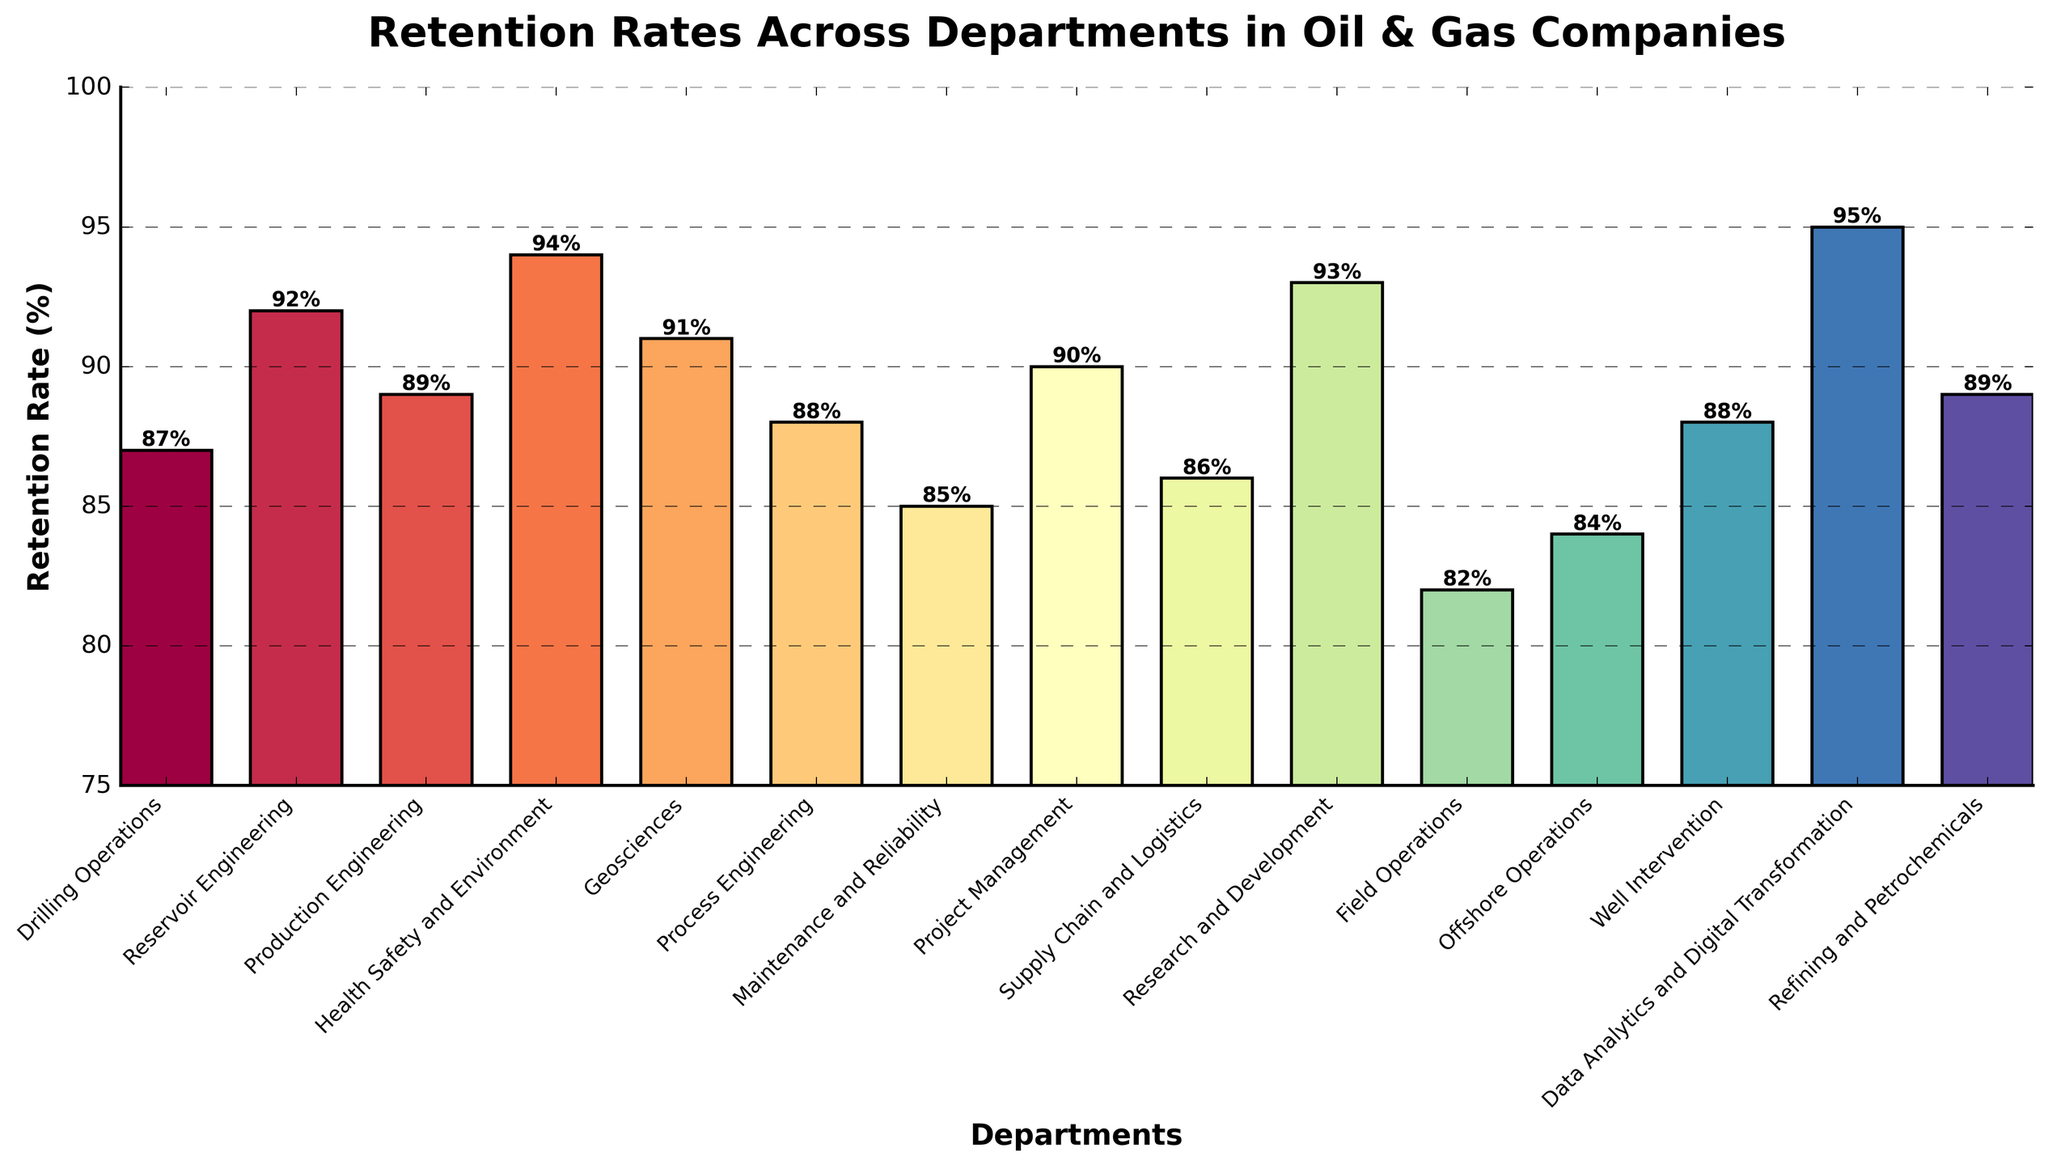What's the retention rate of the Health Safety and Environment department? Locate the bar labeled 'Health Safety and Environment' and observe its height on the y-axis, which shows retention rate. The value is also labeled above the bar.
Answer: 94% Which department has the highest retention rate? Identify the tallest bar in the chart and read the department name labeled below it. The tallest bar corresponds to 'Data Analytics and Digital Transformation' at 95%.
Answer: Data Analytics and Digital Transformation What's the average retention rate across all departments? Add up all the retention rates and then divide by the number of departments. The departments and their retention rates are: (87 + 92 + 89 + 94 + 91 + 88 + 85 + 90 + 86 + 93 + 82 + 84 + 88 + 95 + 89). The total is 1233. There are 15 departments, so the average retention rate is 1233 / 15.
Answer: 82.2% Which department has the lowest retention rate, and what is it? Identify the shortest bar in the chart and read the department name labeled below it. The shortest bar corresponds to 'Field Operations' at 82%.
Answer: Field Operations, 82% How many departments have a retention rate greater than 90%? Count the bars in the chart that extend above the 90% mark on the y-axis. The departments with retention rates above 90% are Reservoir Engineering (92%), Health Safety and Environment (94%), Geosciences (91%), Research and Development (93%), and Data Analytics and Digital Transformation (95%). There are 5 such departments.
Answer: 5 Is the retention rate of Drilling Operations greater than the retention rate of Maintenance and Reliability? Compare the heights of the bars for 'Drilling Operations' and 'Maintenance and Reliability'. Drilling Operations has a retention rate of 87%, while Maintenance and Reliability has a retention rate of 85%.
Answer: Yes Which departments have retention rates that match exactly? Identify bars with the same height and labeled retention rate values. 'Production Engineering' and 'Refining and Petrochemicals' both have a retention rate of 89%. 'Process Engineering' and 'Well Intervention' both have a retention rate of 88%.
Answer: Production Engineering & Refining and Petrochemicals, Process Engineering & Well Intervention What is the difference between the retention rates of Supply Chain and Logistics and Offshore Operations? Find the bars for 'Supply Chain and Logistics' (86%) and 'Offshore Operations' (84%). Subtract the retention rate of Offshore Operations from that of Supply Chain and Logistics. 86% - 84% = 2%.
Answer: 2% What's the sum of retention rates for the departments whose rates are below 90%? Identify the departments with retention rates below 90%, then sum their rates: Drilling Operations (87), Production Engineering (89), Process Engineering (88), Maintenance and Reliability (85), Project Management (90), Supply Chain and Logistics (86), Field Operations (82), Offshore Operations (84), and Well Intervention (88). The sum is (87 + 89 + 88 + 85 + 90 + 86 + 82 + 84 + 88) = 779.
Answer: 779 